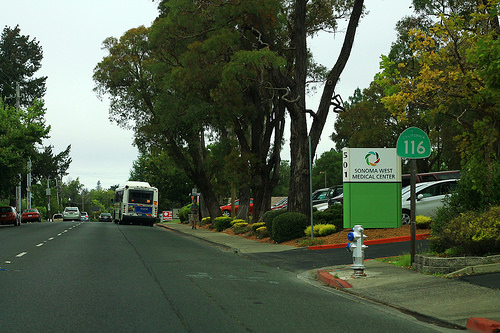<image>
Can you confirm if the sign board is to the left of the car? Yes. From this viewpoint, the sign board is positioned to the left side relative to the car. Where is the fire hydrant in relation to the bus? Is it in front of the bus? No. The fire hydrant is not in front of the bus. The spatial positioning shows a different relationship between these objects. 